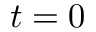Convert formula to latex. <formula><loc_0><loc_0><loc_500><loc_500>t = 0</formula> 